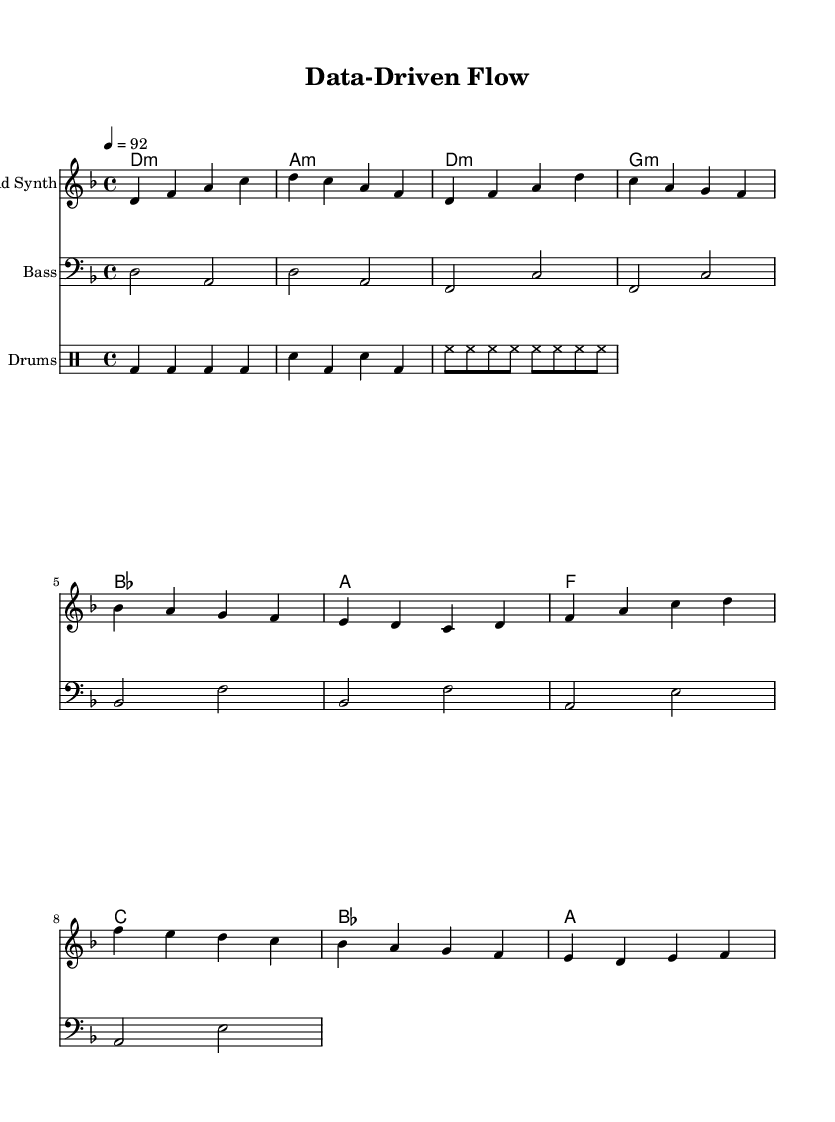What is the key signature of this music? The key signature is D minor, which has one flat (B♭). This can be identified by looking at the key signature section at the beginning of the staff where there is a single flat symbol.
Answer: D minor What is the time signature of this music? The time signature is 4/4, which indicates that there are four beats in each measure and the quarter note gets one beat. This is shown in the meter marking at the beginning of the staff.
Answer: 4/4 What is the tempo marking for this piece? The tempo marking indicates a tempo of 92 beats per minute. This is noted at the beginning of the score, specifying how fast the music should be played.
Answer: 92 What instruments are used in this composition? The instruments included are Lead Synth, Bass, and Drums. This can be deduced from the different staff headings in the score which identify each instrumental part.
Answer: Lead Synth, Bass, Drums How many measures are in the verse section of the music? The verse section includes four measures, marked clearly in the score where the lead synth part is specified. Each measure can be counted from the beginning of the verse phrase until it transitions to the chorus.
Answer: 4 What type of musical pattern do the drums follow? The drums follow a repeated pattern, as seen in the drummode section where similar rhythmic sequences occur throughout. The repeated kick (bd) and snare (sn) patterns reveal a typical hip hop rhythmic structure.
Answer: Repeated Which chord is played at the beginning of the chorus? The chorus begins with the F major chord, as indicated in the harmony part at the start of the chorus section. This is clearly labeled in the chord mode section of the score.
Answer: F 